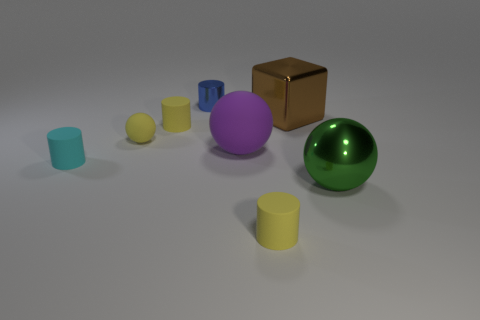Are there any cylinders of the same color as the small matte sphere?
Your answer should be very brief. Yes. There is a small ball; does it have the same color as the small cylinder right of the purple matte object?
Keep it short and to the point. Yes. What number of blue objects are metal things or tiny matte objects?
Offer a very short reply. 1. Are there any other things that are the same color as the metallic block?
Give a very brief answer. No. The large thing that is on the left side of the small yellow thing that is in front of the big green ball is what color?
Make the answer very short. Purple. Is the number of yellow rubber cylinders that are to the right of the large matte object less than the number of objects in front of the big block?
Your answer should be very brief. Yes. How many objects are cylinders that are in front of the brown metal thing or brown metal blocks?
Provide a succinct answer. 4. Do the yellow cylinder left of the metallic cylinder and the shiny cube have the same size?
Ensure brevity in your answer.  No. Is the number of matte spheres that are to the left of the small cyan matte cylinder less than the number of tiny blue cylinders?
Ensure brevity in your answer.  Yes. What is the material of the blue object that is the same size as the cyan matte cylinder?
Give a very brief answer. Metal. 